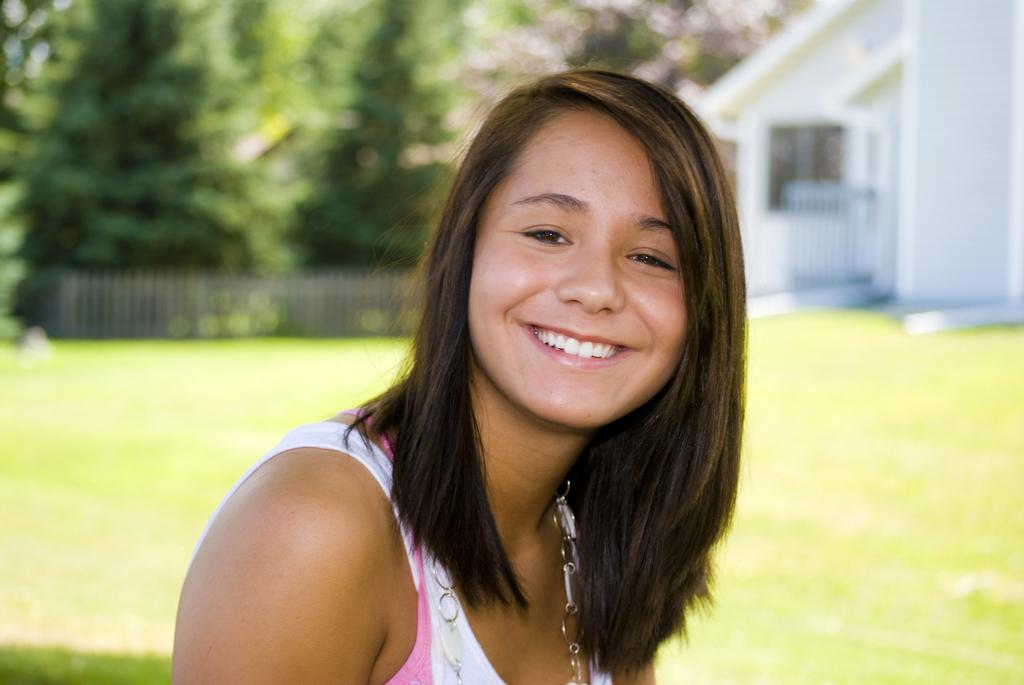What is the person in the image wearing? The person in the image is wearing a white and pink dress. What can be seen in the background of the image? There is a building, railing, and many trees in the background of the image. How is the background of the image depicted? The background of the image is blurred. What type of plot is visible in the image? There is no plot visible in the image; it features a person wearing a dress and a blurred background with a building, railing, and trees. 